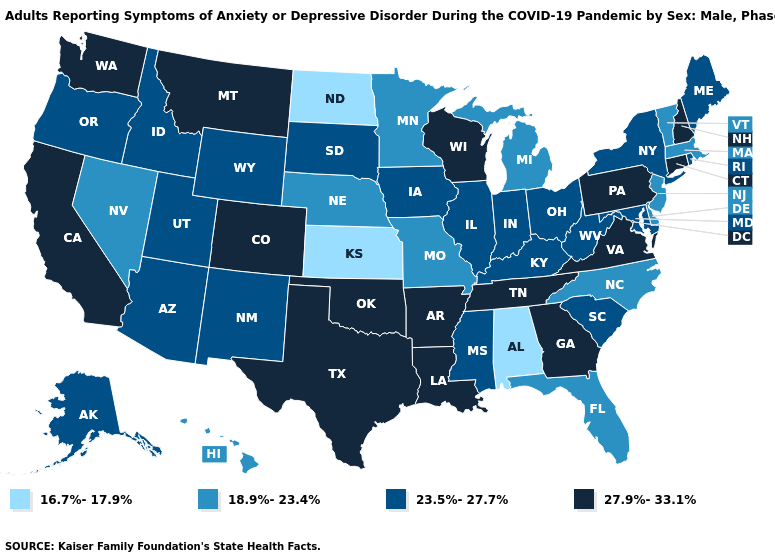What is the value of New Jersey?
Concise answer only. 18.9%-23.4%. Among the states that border Colorado , which have the highest value?
Quick response, please. Oklahoma. What is the value of Minnesota?
Give a very brief answer. 18.9%-23.4%. What is the value of Arkansas?
Write a very short answer. 27.9%-33.1%. Does Nevada have the lowest value in the West?
Keep it brief. Yes. What is the lowest value in states that border Illinois?
Write a very short answer. 18.9%-23.4%. Does Massachusetts have the same value as Michigan?
Write a very short answer. Yes. What is the lowest value in states that border New Mexico?
Write a very short answer. 23.5%-27.7%. Name the states that have a value in the range 16.7%-17.9%?
Keep it brief. Alabama, Kansas, North Dakota. What is the value of South Carolina?
Concise answer only. 23.5%-27.7%. Does New Jersey have the same value as Missouri?
Concise answer only. Yes. What is the highest value in the Northeast ?
Short answer required. 27.9%-33.1%. Which states have the highest value in the USA?
Be succinct. Arkansas, California, Colorado, Connecticut, Georgia, Louisiana, Montana, New Hampshire, Oklahoma, Pennsylvania, Tennessee, Texas, Virginia, Washington, Wisconsin. What is the value of Oregon?
Keep it brief. 23.5%-27.7%. What is the value of Idaho?
Quick response, please. 23.5%-27.7%. 